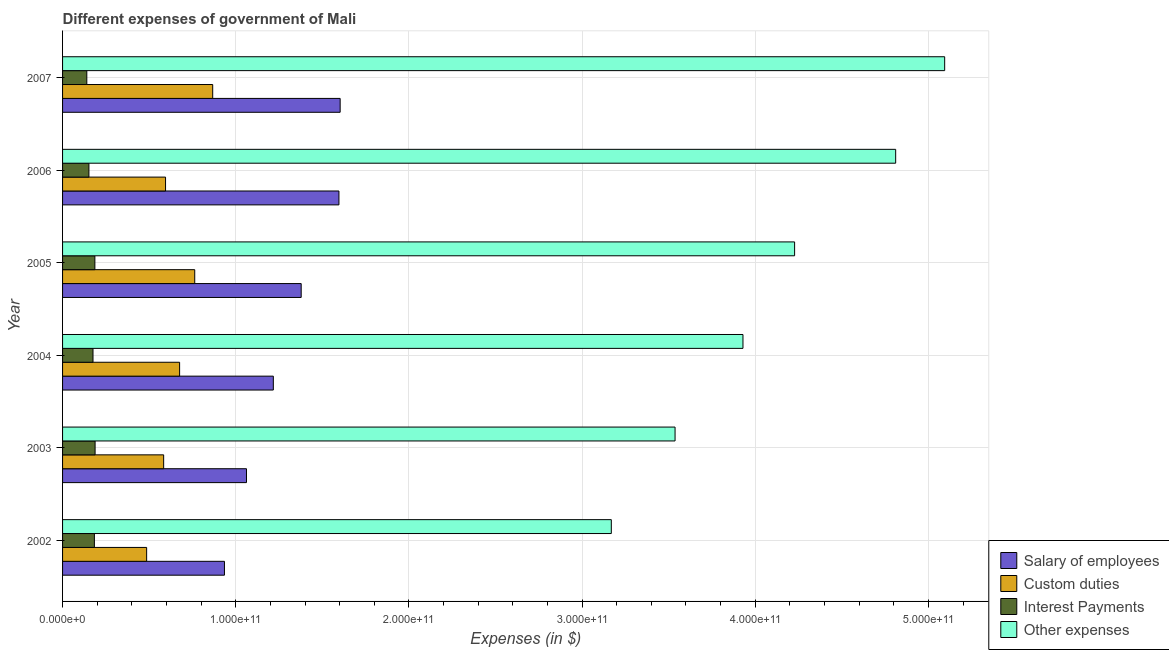How many different coloured bars are there?
Offer a very short reply. 4. What is the amount spent on custom duties in 2006?
Your answer should be very brief. 5.95e+1. Across all years, what is the maximum amount spent on interest payments?
Your response must be concise. 1.88e+1. Across all years, what is the minimum amount spent on custom duties?
Give a very brief answer. 4.86e+1. In which year was the amount spent on interest payments maximum?
Offer a terse response. 2003. In which year was the amount spent on interest payments minimum?
Your response must be concise. 2007. What is the total amount spent on custom duties in the graph?
Keep it short and to the point. 3.97e+11. What is the difference between the amount spent on custom duties in 2002 and that in 2006?
Make the answer very short. -1.09e+1. What is the difference between the amount spent on interest payments in 2004 and the amount spent on salary of employees in 2006?
Give a very brief answer. -1.42e+11. What is the average amount spent on interest payments per year?
Provide a succinct answer. 1.71e+1. In the year 2002, what is the difference between the amount spent on salary of employees and amount spent on other expenses?
Your answer should be compact. -2.23e+11. In how many years, is the amount spent on salary of employees greater than 320000000000 $?
Offer a terse response. 0. What is the ratio of the amount spent on salary of employees in 2003 to that in 2004?
Your response must be concise. 0.87. Is the difference between the amount spent on salary of employees in 2003 and 2004 greater than the difference between the amount spent on other expenses in 2003 and 2004?
Make the answer very short. Yes. What is the difference between the highest and the second highest amount spent on custom duties?
Provide a succinct answer. 1.04e+1. What is the difference between the highest and the lowest amount spent on other expenses?
Your response must be concise. 1.93e+11. In how many years, is the amount spent on interest payments greater than the average amount spent on interest payments taken over all years?
Keep it short and to the point. 4. Is the sum of the amount spent on custom duties in 2005 and 2006 greater than the maximum amount spent on other expenses across all years?
Give a very brief answer. No. What does the 3rd bar from the top in 2003 represents?
Offer a very short reply. Custom duties. What does the 4th bar from the bottom in 2003 represents?
Your response must be concise. Other expenses. How many bars are there?
Offer a very short reply. 24. Are all the bars in the graph horizontal?
Provide a short and direct response. Yes. What is the difference between two consecutive major ticks on the X-axis?
Your answer should be very brief. 1.00e+11. Does the graph contain any zero values?
Ensure brevity in your answer.  No. Does the graph contain grids?
Give a very brief answer. Yes. How many legend labels are there?
Provide a succinct answer. 4. What is the title of the graph?
Keep it short and to the point. Different expenses of government of Mali. What is the label or title of the X-axis?
Your answer should be compact. Expenses (in $). What is the label or title of the Y-axis?
Provide a succinct answer. Year. What is the Expenses (in $) in Salary of employees in 2002?
Your answer should be very brief. 9.35e+1. What is the Expenses (in $) of Custom duties in 2002?
Your response must be concise. 4.86e+1. What is the Expenses (in $) of Interest Payments in 2002?
Your answer should be compact. 1.84e+1. What is the Expenses (in $) in Other expenses in 2002?
Give a very brief answer. 3.17e+11. What is the Expenses (in $) in Salary of employees in 2003?
Offer a very short reply. 1.06e+11. What is the Expenses (in $) in Custom duties in 2003?
Offer a very short reply. 5.84e+1. What is the Expenses (in $) in Interest Payments in 2003?
Give a very brief answer. 1.88e+1. What is the Expenses (in $) in Other expenses in 2003?
Offer a very short reply. 3.54e+11. What is the Expenses (in $) in Salary of employees in 2004?
Provide a succinct answer. 1.22e+11. What is the Expenses (in $) of Custom duties in 2004?
Ensure brevity in your answer.  6.76e+1. What is the Expenses (in $) in Interest Payments in 2004?
Ensure brevity in your answer.  1.76e+1. What is the Expenses (in $) of Other expenses in 2004?
Provide a short and direct response. 3.93e+11. What is the Expenses (in $) in Salary of employees in 2005?
Provide a short and direct response. 1.38e+11. What is the Expenses (in $) of Custom duties in 2005?
Your answer should be very brief. 7.63e+1. What is the Expenses (in $) in Interest Payments in 2005?
Provide a succinct answer. 1.87e+1. What is the Expenses (in $) of Other expenses in 2005?
Provide a short and direct response. 4.23e+11. What is the Expenses (in $) in Salary of employees in 2006?
Offer a very short reply. 1.60e+11. What is the Expenses (in $) in Custom duties in 2006?
Provide a short and direct response. 5.95e+1. What is the Expenses (in $) in Interest Payments in 2006?
Your answer should be very brief. 1.52e+1. What is the Expenses (in $) in Other expenses in 2006?
Your answer should be very brief. 4.81e+11. What is the Expenses (in $) in Salary of employees in 2007?
Offer a very short reply. 1.60e+11. What is the Expenses (in $) in Custom duties in 2007?
Ensure brevity in your answer.  8.67e+1. What is the Expenses (in $) in Interest Payments in 2007?
Offer a very short reply. 1.40e+1. What is the Expenses (in $) of Other expenses in 2007?
Keep it short and to the point. 5.09e+11. Across all years, what is the maximum Expenses (in $) in Salary of employees?
Make the answer very short. 1.60e+11. Across all years, what is the maximum Expenses (in $) of Custom duties?
Your answer should be compact. 8.67e+1. Across all years, what is the maximum Expenses (in $) in Interest Payments?
Your answer should be very brief. 1.88e+1. Across all years, what is the maximum Expenses (in $) of Other expenses?
Your response must be concise. 5.09e+11. Across all years, what is the minimum Expenses (in $) of Salary of employees?
Provide a short and direct response. 9.35e+1. Across all years, what is the minimum Expenses (in $) in Custom duties?
Make the answer very short. 4.86e+1. Across all years, what is the minimum Expenses (in $) in Interest Payments?
Ensure brevity in your answer.  1.40e+1. Across all years, what is the minimum Expenses (in $) of Other expenses?
Give a very brief answer. 3.17e+11. What is the total Expenses (in $) in Salary of employees in the graph?
Your answer should be compact. 7.79e+11. What is the total Expenses (in $) of Custom duties in the graph?
Provide a short and direct response. 3.97e+11. What is the total Expenses (in $) in Interest Payments in the graph?
Offer a terse response. 1.03e+11. What is the total Expenses (in $) in Other expenses in the graph?
Your response must be concise. 2.48e+12. What is the difference between the Expenses (in $) in Salary of employees in 2002 and that in 2003?
Ensure brevity in your answer.  -1.27e+1. What is the difference between the Expenses (in $) of Custom duties in 2002 and that in 2003?
Offer a terse response. -9.82e+09. What is the difference between the Expenses (in $) of Interest Payments in 2002 and that in 2003?
Offer a very short reply. -4.08e+08. What is the difference between the Expenses (in $) in Other expenses in 2002 and that in 2003?
Ensure brevity in your answer.  -3.68e+1. What is the difference between the Expenses (in $) of Salary of employees in 2002 and that in 2004?
Offer a very short reply. -2.82e+1. What is the difference between the Expenses (in $) of Custom duties in 2002 and that in 2004?
Provide a short and direct response. -1.90e+1. What is the difference between the Expenses (in $) in Interest Payments in 2002 and that in 2004?
Offer a very short reply. 8.02e+08. What is the difference between the Expenses (in $) of Other expenses in 2002 and that in 2004?
Keep it short and to the point. -7.60e+1. What is the difference between the Expenses (in $) of Salary of employees in 2002 and that in 2005?
Provide a succinct answer. -4.43e+1. What is the difference between the Expenses (in $) of Custom duties in 2002 and that in 2005?
Your response must be concise. -2.78e+1. What is the difference between the Expenses (in $) of Interest Payments in 2002 and that in 2005?
Provide a succinct answer. -2.80e+08. What is the difference between the Expenses (in $) in Other expenses in 2002 and that in 2005?
Keep it short and to the point. -1.06e+11. What is the difference between the Expenses (in $) in Salary of employees in 2002 and that in 2006?
Your response must be concise. -6.61e+1. What is the difference between the Expenses (in $) in Custom duties in 2002 and that in 2006?
Provide a short and direct response. -1.09e+1. What is the difference between the Expenses (in $) in Interest Payments in 2002 and that in 2006?
Ensure brevity in your answer.  3.16e+09. What is the difference between the Expenses (in $) of Other expenses in 2002 and that in 2006?
Make the answer very short. -1.64e+11. What is the difference between the Expenses (in $) in Salary of employees in 2002 and that in 2007?
Offer a very short reply. -6.68e+1. What is the difference between the Expenses (in $) of Custom duties in 2002 and that in 2007?
Offer a terse response. -3.81e+1. What is the difference between the Expenses (in $) of Interest Payments in 2002 and that in 2007?
Offer a very short reply. 4.38e+09. What is the difference between the Expenses (in $) in Other expenses in 2002 and that in 2007?
Provide a succinct answer. -1.93e+11. What is the difference between the Expenses (in $) in Salary of employees in 2003 and that in 2004?
Make the answer very short. -1.55e+1. What is the difference between the Expenses (in $) in Custom duties in 2003 and that in 2004?
Your response must be concise. -9.22e+09. What is the difference between the Expenses (in $) in Interest Payments in 2003 and that in 2004?
Give a very brief answer. 1.21e+09. What is the difference between the Expenses (in $) in Other expenses in 2003 and that in 2004?
Make the answer very short. -3.92e+1. What is the difference between the Expenses (in $) in Salary of employees in 2003 and that in 2005?
Ensure brevity in your answer.  -3.16e+1. What is the difference between the Expenses (in $) in Custom duties in 2003 and that in 2005?
Ensure brevity in your answer.  -1.79e+1. What is the difference between the Expenses (in $) of Interest Payments in 2003 and that in 2005?
Your answer should be compact. 1.27e+08. What is the difference between the Expenses (in $) in Other expenses in 2003 and that in 2005?
Give a very brief answer. -6.90e+1. What is the difference between the Expenses (in $) of Salary of employees in 2003 and that in 2006?
Offer a very short reply. -5.34e+1. What is the difference between the Expenses (in $) in Custom duties in 2003 and that in 2006?
Offer a terse response. -1.10e+09. What is the difference between the Expenses (in $) in Interest Payments in 2003 and that in 2006?
Offer a terse response. 3.57e+09. What is the difference between the Expenses (in $) in Other expenses in 2003 and that in 2006?
Your answer should be compact. -1.27e+11. What is the difference between the Expenses (in $) of Salary of employees in 2003 and that in 2007?
Your answer should be very brief. -5.41e+1. What is the difference between the Expenses (in $) in Custom duties in 2003 and that in 2007?
Your answer should be compact. -2.83e+1. What is the difference between the Expenses (in $) of Interest Payments in 2003 and that in 2007?
Your answer should be very brief. 4.79e+09. What is the difference between the Expenses (in $) of Other expenses in 2003 and that in 2007?
Offer a very short reply. -1.56e+11. What is the difference between the Expenses (in $) in Salary of employees in 2004 and that in 2005?
Make the answer very short. -1.61e+1. What is the difference between the Expenses (in $) of Custom duties in 2004 and that in 2005?
Your answer should be very brief. -8.73e+09. What is the difference between the Expenses (in $) of Interest Payments in 2004 and that in 2005?
Offer a very short reply. -1.08e+09. What is the difference between the Expenses (in $) of Other expenses in 2004 and that in 2005?
Your answer should be very brief. -2.98e+1. What is the difference between the Expenses (in $) in Salary of employees in 2004 and that in 2006?
Offer a terse response. -3.79e+1. What is the difference between the Expenses (in $) in Custom duties in 2004 and that in 2006?
Make the answer very short. 8.12e+09. What is the difference between the Expenses (in $) in Interest Payments in 2004 and that in 2006?
Offer a very short reply. 2.36e+09. What is the difference between the Expenses (in $) of Other expenses in 2004 and that in 2006?
Provide a succinct answer. -8.82e+1. What is the difference between the Expenses (in $) of Salary of employees in 2004 and that in 2007?
Offer a very short reply. -3.86e+1. What is the difference between the Expenses (in $) in Custom duties in 2004 and that in 2007?
Provide a short and direct response. -1.91e+1. What is the difference between the Expenses (in $) in Interest Payments in 2004 and that in 2007?
Provide a succinct answer. 3.58e+09. What is the difference between the Expenses (in $) in Other expenses in 2004 and that in 2007?
Your answer should be compact. -1.16e+11. What is the difference between the Expenses (in $) of Salary of employees in 2005 and that in 2006?
Your response must be concise. -2.18e+1. What is the difference between the Expenses (in $) in Custom duties in 2005 and that in 2006?
Make the answer very short. 1.68e+1. What is the difference between the Expenses (in $) in Interest Payments in 2005 and that in 2006?
Give a very brief answer. 3.44e+09. What is the difference between the Expenses (in $) in Other expenses in 2005 and that in 2006?
Give a very brief answer. -5.84e+1. What is the difference between the Expenses (in $) in Salary of employees in 2005 and that in 2007?
Keep it short and to the point. -2.25e+1. What is the difference between the Expenses (in $) of Custom duties in 2005 and that in 2007?
Ensure brevity in your answer.  -1.04e+1. What is the difference between the Expenses (in $) of Interest Payments in 2005 and that in 2007?
Provide a short and direct response. 4.66e+09. What is the difference between the Expenses (in $) of Other expenses in 2005 and that in 2007?
Your answer should be very brief. -8.67e+1. What is the difference between the Expenses (in $) of Salary of employees in 2006 and that in 2007?
Your answer should be compact. -7.02e+08. What is the difference between the Expenses (in $) of Custom duties in 2006 and that in 2007?
Ensure brevity in your answer.  -2.72e+1. What is the difference between the Expenses (in $) in Interest Payments in 2006 and that in 2007?
Your response must be concise. 1.22e+09. What is the difference between the Expenses (in $) of Other expenses in 2006 and that in 2007?
Your response must be concise. -2.83e+1. What is the difference between the Expenses (in $) in Salary of employees in 2002 and the Expenses (in $) in Custom duties in 2003?
Offer a very short reply. 3.51e+1. What is the difference between the Expenses (in $) in Salary of employees in 2002 and the Expenses (in $) in Interest Payments in 2003?
Provide a short and direct response. 7.47e+1. What is the difference between the Expenses (in $) of Salary of employees in 2002 and the Expenses (in $) of Other expenses in 2003?
Provide a succinct answer. -2.60e+11. What is the difference between the Expenses (in $) of Custom duties in 2002 and the Expenses (in $) of Interest Payments in 2003?
Keep it short and to the point. 2.98e+1. What is the difference between the Expenses (in $) in Custom duties in 2002 and the Expenses (in $) in Other expenses in 2003?
Provide a short and direct response. -3.05e+11. What is the difference between the Expenses (in $) in Interest Payments in 2002 and the Expenses (in $) in Other expenses in 2003?
Give a very brief answer. -3.35e+11. What is the difference between the Expenses (in $) in Salary of employees in 2002 and the Expenses (in $) in Custom duties in 2004?
Your answer should be very brief. 2.59e+1. What is the difference between the Expenses (in $) of Salary of employees in 2002 and the Expenses (in $) of Interest Payments in 2004?
Provide a short and direct response. 7.59e+1. What is the difference between the Expenses (in $) in Salary of employees in 2002 and the Expenses (in $) in Other expenses in 2004?
Make the answer very short. -2.99e+11. What is the difference between the Expenses (in $) in Custom duties in 2002 and the Expenses (in $) in Interest Payments in 2004?
Your answer should be compact. 3.10e+1. What is the difference between the Expenses (in $) in Custom duties in 2002 and the Expenses (in $) in Other expenses in 2004?
Offer a very short reply. -3.44e+11. What is the difference between the Expenses (in $) in Interest Payments in 2002 and the Expenses (in $) in Other expenses in 2004?
Keep it short and to the point. -3.75e+11. What is the difference between the Expenses (in $) in Salary of employees in 2002 and the Expenses (in $) in Custom duties in 2005?
Give a very brief answer. 1.72e+1. What is the difference between the Expenses (in $) of Salary of employees in 2002 and the Expenses (in $) of Interest Payments in 2005?
Provide a short and direct response. 7.48e+1. What is the difference between the Expenses (in $) in Salary of employees in 2002 and the Expenses (in $) in Other expenses in 2005?
Make the answer very short. -3.29e+11. What is the difference between the Expenses (in $) of Custom duties in 2002 and the Expenses (in $) of Interest Payments in 2005?
Keep it short and to the point. 2.99e+1. What is the difference between the Expenses (in $) in Custom duties in 2002 and the Expenses (in $) in Other expenses in 2005?
Provide a succinct answer. -3.74e+11. What is the difference between the Expenses (in $) in Interest Payments in 2002 and the Expenses (in $) in Other expenses in 2005?
Your answer should be compact. -4.04e+11. What is the difference between the Expenses (in $) in Salary of employees in 2002 and the Expenses (in $) in Custom duties in 2006?
Provide a short and direct response. 3.40e+1. What is the difference between the Expenses (in $) of Salary of employees in 2002 and the Expenses (in $) of Interest Payments in 2006?
Make the answer very short. 7.83e+1. What is the difference between the Expenses (in $) in Salary of employees in 2002 and the Expenses (in $) in Other expenses in 2006?
Your answer should be compact. -3.88e+11. What is the difference between the Expenses (in $) of Custom duties in 2002 and the Expenses (in $) of Interest Payments in 2006?
Ensure brevity in your answer.  3.33e+1. What is the difference between the Expenses (in $) in Custom duties in 2002 and the Expenses (in $) in Other expenses in 2006?
Offer a very short reply. -4.33e+11. What is the difference between the Expenses (in $) in Interest Payments in 2002 and the Expenses (in $) in Other expenses in 2006?
Provide a short and direct response. -4.63e+11. What is the difference between the Expenses (in $) in Salary of employees in 2002 and the Expenses (in $) in Custom duties in 2007?
Ensure brevity in your answer.  6.79e+09. What is the difference between the Expenses (in $) in Salary of employees in 2002 and the Expenses (in $) in Interest Payments in 2007?
Your response must be concise. 7.95e+1. What is the difference between the Expenses (in $) of Salary of employees in 2002 and the Expenses (in $) of Other expenses in 2007?
Your answer should be compact. -4.16e+11. What is the difference between the Expenses (in $) of Custom duties in 2002 and the Expenses (in $) of Interest Payments in 2007?
Offer a very short reply. 3.46e+1. What is the difference between the Expenses (in $) of Custom duties in 2002 and the Expenses (in $) of Other expenses in 2007?
Make the answer very short. -4.61e+11. What is the difference between the Expenses (in $) in Interest Payments in 2002 and the Expenses (in $) in Other expenses in 2007?
Your response must be concise. -4.91e+11. What is the difference between the Expenses (in $) of Salary of employees in 2003 and the Expenses (in $) of Custom duties in 2004?
Keep it short and to the point. 3.86e+1. What is the difference between the Expenses (in $) in Salary of employees in 2003 and the Expenses (in $) in Interest Payments in 2004?
Your answer should be compact. 8.86e+1. What is the difference between the Expenses (in $) of Salary of employees in 2003 and the Expenses (in $) of Other expenses in 2004?
Give a very brief answer. -2.87e+11. What is the difference between the Expenses (in $) in Custom duties in 2003 and the Expenses (in $) in Interest Payments in 2004?
Keep it short and to the point. 4.08e+1. What is the difference between the Expenses (in $) in Custom duties in 2003 and the Expenses (in $) in Other expenses in 2004?
Provide a succinct answer. -3.35e+11. What is the difference between the Expenses (in $) in Interest Payments in 2003 and the Expenses (in $) in Other expenses in 2004?
Keep it short and to the point. -3.74e+11. What is the difference between the Expenses (in $) in Salary of employees in 2003 and the Expenses (in $) in Custom duties in 2005?
Keep it short and to the point. 2.99e+1. What is the difference between the Expenses (in $) of Salary of employees in 2003 and the Expenses (in $) of Interest Payments in 2005?
Provide a succinct answer. 8.75e+1. What is the difference between the Expenses (in $) in Salary of employees in 2003 and the Expenses (in $) in Other expenses in 2005?
Your response must be concise. -3.17e+11. What is the difference between the Expenses (in $) of Custom duties in 2003 and the Expenses (in $) of Interest Payments in 2005?
Provide a short and direct response. 3.97e+1. What is the difference between the Expenses (in $) in Custom duties in 2003 and the Expenses (in $) in Other expenses in 2005?
Your answer should be compact. -3.64e+11. What is the difference between the Expenses (in $) in Interest Payments in 2003 and the Expenses (in $) in Other expenses in 2005?
Offer a very short reply. -4.04e+11. What is the difference between the Expenses (in $) in Salary of employees in 2003 and the Expenses (in $) in Custom duties in 2006?
Keep it short and to the point. 4.67e+1. What is the difference between the Expenses (in $) of Salary of employees in 2003 and the Expenses (in $) of Interest Payments in 2006?
Keep it short and to the point. 9.10e+1. What is the difference between the Expenses (in $) in Salary of employees in 2003 and the Expenses (in $) in Other expenses in 2006?
Make the answer very short. -3.75e+11. What is the difference between the Expenses (in $) of Custom duties in 2003 and the Expenses (in $) of Interest Payments in 2006?
Keep it short and to the point. 4.32e+1. What is the difference between the Expenses (in $) in Custom duties in 2003 and the Expenses (in $) in Other expenses in 2006?
Your answer should be compact. -4.23e+11. What is the difference between the Expenses (in $) of Interest Payments in 2003 and the Expenses (in $) of Other expenses in 2006?
Offer a very short reply. -4.62e+11. What is the difference between the Expenses (in $) in Salary of employees in 2003 and the Expenses (in $) in Custom duties in 2007?
Your answer should be very brief. 1.95e+1. What is the difference between the Expenses (in $) of Salary of employees in 2003 and the Expenses (in $) of Interest Payments in 2007?
Provide a succinct answer. 9.22e+1. What is the difference between the Expenses (in $) of Salary of employees in 2003 and the Expenses (in $) of Other expenses in 2007?
Ensure brevity in your answer.  -4.03e+11. What is the difference between the Expenses (in $) in Custom duties in 2003 and the Expenses (in $) in Interest Payments in 2007?
Keep it short and to the point. 4.44e+1. What is the difference between the Expenses (in $) of Custom duties in 2003 and the Expenses (in $) of Other expenses in 2007?
Keep it short and to the point. -4.51e+11. What is the difference between the Expenses (in $) of Interest Payments in 2003 and the Expenses (in $) of Other expenses in 2007?
Provide a succinct answer. -4.91e+11. What is the difference between the Expenses (in $) in Salary of employees in 2004 and the Expenses (in $) in Custom duties in 2005?
Your answer should be compact. 4.54e+1. What is the difference between the Expenses (in $) in Salary of employees in 2004 and the Expenses (in $) in Interest Payments in 2005?
Keep it short and to the point. 1.03e+11. What is the difference between the Expenses (in $) in Salary of employees in 2004 and the Expenses (in $) in Other expenses in 2005?
Your answer should be compact. -3.01e+11. What is the difference between the Expenses (in $) in Custom duties in 2004 and the Expenses (in $) in Interest Payments in 2005?
Provide a succinct answer. 4.89e+1. What is the difference between the Expenses (in $) of Custom duties in 2004 and the Expenses (in $) of Other expenses in 2005?
Make the answer very short. -3.55e+11. What is the difference between the Expenses (in $) in Interest Payments in 2004 and the Expenses (in $) in Other expenses in 2005?
Your answer should be compact. -4.05e+11. What is the difference between the Expenses (in $) in Salary of employees in 2004 and the Expenses (in $) in Custom duties in 2006?
Ensure brevity in your answer.  6.22e+1. What is the difference between the Expenses (in $) of Salary of employees in 2004 and the Expenses (in $) of Interest Payments in 2006?
Your response must be concise. 1.06e+11. What is the difference between the Expenses (in $) in Salary of employees in 2004 and the Expenses (in $) in Other expenses in 2006?
Your answer should be very brief. -3.59e+11. What is the difference between the Expenses (in $) of Custom duties in 2004 and the Expenses (in $) of Interest Payments in 2006?
Make the answer very short. 5.24e+1. What is the difference between the Expenses (in $) in Custom duties in 2004 and the Expenses (in $) in Other expenses in 2006?
Your answer should be compact. -4.14e+11. What is the difference between the Expenses (in $) of Interest Payments in 2004 and the Expenses (in $) of Other expenses in 2006?
Make the answer very short. -4.64e+11. What is the difference between the Expenses (in $) in Salary of employees in 2004 and the Expenses (in $) in Custom duties in 2007?
Keep it short and to the point. 3.50e+1. What is the difference between the Expenses (in $) in Salary of employees in 2004 and the Expenses (in $) in Interest Payments in 2007?
Give a very brief answer. 1.08e+11. What is the difference between the Expenses (in $) in Salary of employees in 2004 and the Expenses (in $) in Other expenses in 2007?
Ensure brevity in your answer.  -3.88e+11. What is the difference between the Expenses (in $) of Custom duties in 2004 and the Expenses (in $) of Interest Payments in 2007?
Your response must be concise. 5.36e+1. What is the difference between the Expenses (in $) of Custom duties in 2004 and the Expenses (in $) of Other expenses in 2007?
Make the answer very short. -4.42e+11. What is the difference between the Expenses (in $) in Interest Payments in 2004 and the Expenses (in $) in Other expenses in 2007?
Your answer should be very brief. -4.92e+11. What is the difference between the Expenses (in $) of Salary of employees in 2005 and the Expenses (in $) of Custom duties in 2006?
Keep it short and to the point. 7.83e+1. What is the difference between the Expenses (in $) of Salary of employees in 2005 and the Expenses (in $) of Interest Payments in 2006?
Your response must be concise. 1.23e+11. What is the difference between the Expenses (in $) of Salary of employees in 2005 and the Expenses (in $) of Other expenses in 2006?
Offer a terse response. -3.43e+11. What is the difference between the Expenses (in $) of Custom duties in 2005 and the Expenses (in $) of Interest Payments in 2006?
Offer a very short reply. 6.11e+1. What is the difference between the Expenses (in $) of Custom duties in 2005 and the Expenses (in $) of Other expenses in 2006?
Offer a very short reply. -4.05e+11. What is the difference between the Expenses (in $) in Interest Payments in 2005 and the Expenses (in $) in Other expenses in 2006?
Offer a terse response. -4.62e+11. What is the difference between the Expenses (in $) in Salary of employees in 2005 and the Expenses (in $) in Custom duties in 2007?
Your answer should be very brief. 5.11e+1. What is the difference between the Expenses (in $) in Salary of employees in 2005 and the Expenses (in $) in Interest Payments in 2007?
Provide a succinct answer. 1.24e+11. What is the difference between the Expenses (in $) of Salary of employees in 2005 and the Expenses (in $) of Other expenses in 2007?
Your answer should be compact. -3.72e+11. What is the difference between the Expenses (in $) of Custom duties in 2005 and the Expenses (in $) of Interest Payments in 2007?
Make the answer very short. 6.23e+1. What is the difference between the Expenses (in $) in Custom duties in 2005 and the Expenses (in $) in Other expenses in 2007?
Your answer should be compact. -4.33e+11. What is the difference between the Expenses (in $) in Interest Payments in 2005 and the Expenses (in $) in Other expenses in 2007?
Your answer should be compact. -4.91e+11. What is the difference between the Expenses (in $) in Salary of employees in 2006 and the Expenses (in $) in Custom duties in 2007?
Give a very brief answer. 7.29e+1. What is the difference between the Expenses (in $) of Salary of employees in 2006 and the Expenses (in $) of Interest Payments in 2007?
Ensure brevity in your answer.  1.46e+11. What is the difference between the Expenses (in $) of Salary of employees in 2006 and the Expenses (in $) of Other expenses in 2007?
Ensure brevity in your answer.  -3.50e+11. What is the difference between the Expenses (in $) of Custom duties in 2006 and the Expenses (in $) of Interest Payments in 2007?
Give a very brief answer. 4.55e+1. What is the difference between the Expenses (in $) of Custom duties in 2006 and the Expenses (in $) of Other expenses in 2007?
Keep it short and to the point. -4.50e+11. What is the difference between the Expenses (in $) in Interest Payments in 2006 and the Expenses (in $) in Other expenses in 2007?
Provide a succinct answer. -4.94e+11. What is the average Expenses (in $) of Salary of employees per year?
Your answer should be compact. 1.30e+11. What is the average Expenses (in $) of Custom duties per year?
Your response must be concise. 6.62e+1. What is the average Expenses (in $) of Interest Payments per year?
Keep it short and to the point. 1.71e+1. What is the average Expenses (in $) of Other expenses per year?
Keep it short and to the point. 4.13e+11. In the year 2002, what is the difference between the Expenses (in $) of Salary of employees and Expenses (in $) of Custom duties?
Your answer should be very brief. 4.49e+1. In the year 2002, what is the difference between the Expenses (in $) of Salary of employees and Expenses (in $) of Interest Payments?
Offer a very short reply. 7.51e+1. In the year 2002, what is the difference between the Expenses (in $) of Salary of employees and Expenses (in $) of Other expenses?
Your answer should be compact. -2.23e+11. In the year 2002, what is the difference between the Expenses (in $) of Custom duties and Expenses (in $) of Interest Payments?
Offer a terse response. 3.02e+1. In the year 2002, what is the difference between the Expenses (in $) in Custom duties and Expenses (in $) in Other expenses?
Provide a short and direct response. -2.68e+11. In the year 2002, what is the difference between the Expenses (in $) of Interest Payments and Expenses (in $) of Other expenses?
Your answer should be compact. -2.99e+11. In the year 2003, what is the difference between the Expenses (in $) in Salary of employees and Expenses (in $) in Custom duties?
Offer a very short reply. 4.78e+1. In the year 2003, what is the difference between the Expenses (in $) in Salary of employees and Expenses (in $) in Interest Payments?
Your response must be concise. 8.74e+1. In the year 2003, what is the difference between the Expenses (in $) of Salary of employees and Expenses (in $) of Other expenses?
Keep it short and to the point. -2.47e+11. In the year 2003, what is the difference between the Expenses (in $) of Custom duties and Expenses (in $) of Interest Payments?
Your answer should be compact. 3.96e+1. In the year 2003, what is the difference between the Expenses (in $) of Custom duties and Expenses (in $) of Other expenses?
Your response must be concise. -2.95e+11. In the year 2003, what is the difference between the Expenses (in $) of Interest Payments and Expenses (in $) of Other expenses?
Provide a short and direct response. -3.35e+11. In the year 2004, what is the difference between the Expenses (in $) in Salary of employees and Expenses (in $) in Custom duties?
Ensure brevity in your answer.  5.41e+1. In the year 2004, what is the difference between the Expenses (in $) in Salary of employees and Expenses (in $) in Interest Payments?
Ensure brevity in your answer.  1.04e+11. In the year 2004, what is the difference between the Expenses (in $) of Salary of employees and Expenses (in $) of Other expenses?
Provide a short and direct response. -2.71e+11. In the year 2004, what is the difference between the Expenses (in $) in Custom duties and Expenses (in $) in Interest Payments?
Ensure brevity in your answer.  5.00e+1. In the year 2004, what is the difference between the Expenses (in $) in Custom duties and Expenses (in $) in Other expenses?
Provide a succinct answer. -3.25e+11. In the year 2004, what is the difference between the Expenses (in $) in Interest Payments and Expenses (in $) in Other expenses?
Provide a succinct answer. -3.75e+11. In the year 2005, what is the difference between the Expenses (in $) of Salary of employees and Expenses (in $) of Custom duties?
Your answer should be compact. 6.15e+1. In the year 2005, what is the difference between the Expenses (in $) of Salary of employees and Expenses (in $) of Interest Payments?
Offer a very short reply. 1.19e+11. In the year 2005, what is the difference between the Expenses (in $) in Salary of employees and Expenses (in $) in Other expenses?
Provide a succinct answer. -2.85e+11. In the year 2005, what is the difference between the Expenses (in $) in Custom duties and Expenses (in $) in Interest Payments?
Make the answer very short. 5.77e+1. In the year 2005, what is the difference between the Expenses (in $) in Custom duties and Expenses (in $) in Other expenses?
Provide a short and direct response. -3.46e+11. In the year 2005, what is the difference between the Expenses (in $) of Interest Payments and Expenses (in $) of Other expenses?
Offer a terse response. -4.04e+11. In the year 2006, what is the difference between the Expenses (in $) in Salary of employees and Expenses (in $) in Custom duties?
Give a very brief answer. 1.00e+11. In the year 2006, what is the difference between the Expenses (in $) of Salary of employees and Expenses (in $) of Interest Payments?
Provide a short and direct response. 1.44e+11. In the year 2006, what is the difference between the Expenses (in $) in Salary of employees and Expenses (in $) in Other expenses?
Your answer should be very brief. -3.22e+11. In the year 2006, what is the difference between the Expenses (in $) of Custom duties and Expenses (in $) of Interest Payments?
Provide a succinct answer. 4.43e+1. In the year 2006, what is the difference between the Expenses (in $) of Custom duties and Expenses (in $) of Other expenses?
Make the answer very short. -4.22e+11. In the year 2006, what is the difference between the Expenses (in $) of Interest Payments and Expenses (in $) of Other expenses?
Offer a terse response. -4.66e+11. In the year 2007, what is the difference between the Expenses (in $) in Salary of employees and Expenses (in $) in Custom duties?
Provide a short and direct response. 7.36e+1. In the year 2007, what is the difference between the Expenses (in $) of Salary of employees and Expenses (in $) of Interest Payments?
Your response must be concise. 1.46e+11. In the year 2007, what is the difference between the Expenses (in $) of Salary of employees and Expenses (in $) of Other expenses?
Offer a very short reply. -3.49e+11. In the year 2007, what is the difference between the Expenses (in $) of Custom duties and Expenses (in $) of Interest Payments?
Your response must be concise. 7.27e+1. In the year 2007, what is the difference between the Expenses (in $) of Custom duties and Expenses (in $) of Other expenses?
Offer a terse response. -4.23e+11. In the year 2007, what is the difference between the Expenses (in $) of Interest Payments and Expenses (in $) of Other expenses?
Provide a succinct answer. -4.95e+11. What is the ratio of the Expenses (in $) in Salary of employees in 2002 to that in 2003?
Offer a terse response. 0.88. What is the ratio of the Expenses (in $) in Custom duties in 2002 to that in 2003?
Provide a short and direct response. 0.83. What is the ratio of the Expenses (in $) in Interest Payments in 2002 to that in 2003?
Your answer should be compact. 0.98. What is the ratio of the Expenses (in $) of Other expenses in 2002 to that in 2003?
Give a very brief answer. 0.9. What is the ratio of the Expenses (in $) in Salary of employees in 2002 to that in 2004?
Your response must be concise. 0.77. What is the ratio of the Expenses (in $) of Custom duties in 2002 to that in 2004?
Ensure brevity in your answer.  0.72. What is the ratio of the Expenses (in $) of Interest Payments in 2002 to that in 2004?
Provide a short and direct response. 1.05. What is the ratio of the Expenses (in $) of Other expenses in 2002 to that in 2004?
Make the answer very short. 0.81. What is the ratio of the Expenses (in $) in Salary of employees in 2002 to that in 2005?
Your answer should be compact. 0.68. What is the ratio of the Expenses (in $) of Custom duties in 2002 to that in 2005?
Your answer should be very brief. 0.64. What is the ratio of the Expenses (in $) in Other expenses in 2002 to that in 2005?
Your answer should be very brief. 0.75. What is the ratio of the Expenses (in $) of Salary of employees in 2002 to that in 2006?
Keep it short and to the point. 0.59. What is the ratio of the Expenses (in $) in Custom duties in 2002 to that in 2006?
Give a very brief answer. 0.82. What is the ratio of the Expenses (in $) in Interest Payments in 2002 to that in 2006?
Your response must be concise. 1.21. What is the ratio of the Expenses (in $) of Other expenses in 2002 to that in 2006?
Make the answer very short. 0.66. What is the ratio of the Expenses (in $) of Salary of employees in 2002 to that in 2007?
Make the answer very short. 0.58. What is the ratio of the Expenses (in $) in Custom duties in 2002 to that in 2007?
Keep it short and to the point. 0.56. What is the ratio of the Expenses (in $) of Interest Payments in 2002 to that in 2007?
Your answer should be compact. 1.31. What is the ratio of the Expenses (in $) in Other expenses in 2002 to that in 2007?
Ensure brevity in your answer.  0.62. What is the ratio of the Expenses (in $) in Salary of employees in 2003 to that in 2004?
Provide a short and direct response. 0.87. What is the ratio of the Expenses (in $) of Custom duties in 2003 to that in 2004?
Your response must be concise. 0.86. What is the ratio of the Expenses (in $) in Interest Payments in 2003 to that in 2004?
Provide a short and direct response. 1.07. What is the ratio of the Expenses (in $) of Other expenses in 2003 to that in 2004?
Offer a very short reply. 0.9. What is the ratio of the Expenses (in $) of Salary of employees in 2003 to that in 2005?
Give a very brief answer. 0.77. What is the ratio of the Expenses (in $) of Custom duties in 2003 to that in 2005?
Your answer should be compact. 0.76. What is the ratio of the Expenses (in $) of Interest Payments in 2003 to that in 2005?
Make the answer very short. 1.01. What is the ratio of the Expenses (in $) of Other expenses in 2003 to that in 2005?
Give a very brief answer. 0.84. What is the ratio of the Expenses (in $) of Salary of employees in 2003 to that in 2006?
Ensure brevity in your answer.  0.67. What is the ratio of the Expenses (in $) in Custom duties in 2003 to that in 2006?
Offer a terse response. 0.98. What is the ratio of the Expenses (in $) of Interest Payments in 2003 to that in 2006?
Provide a short and direct response. 1.23. What is the ratio of the Expenses (in $) of Other expenses in 2003 to that in 2006?
Make the answer very short. 0.74. What is the ratio of the Expenses (in $) in Salary of employees in 2003 to that in 2007?
Keep it short and to the point. 0.66. What is the ratio of the Expenses (in $) in Custom duties in 2003 to that in 2007?
Provide a short and direct response. 0.67. What is the ratio of the Expenses (in $) of Interest Payments in 2003 to that in 2007?
Keep it short and to the point. 1.34. What is the ratio of the Expenses (in $) in Other expenses in 2003 to that in 2007?
Provide a short and direct response. 0.69. What is the ratio of the Expenses (in $) of Salary of employees in 2004 to that in 2005?
Your answer should be compact. 0.88. What is the ratio of the Expenses (in $) in Custom duties in 2004 to that in 2005?
Give a very brief answer. 0.89. What is the ratio of the Expenses (in $) in Interest Payments in 2004 to that in 2005?
Offer a very short reply. 0.94. What is the ratio of the Expenses (in $) of Other expenses in 2004 to that in 2005?
Provide a succinct answer. 0.93. What is the ratio of the Expenses (in $) in Salary of employees in 2004 to that in 2006?
Your answer should be very brief. 0.76. What is the ratio of the Expenses (in $) in Custom duties in 2004 to that in 2006?
Keep it short and to the point. 1.14. What is the ratio of the Expenses (in $) in Interest Payments in 2004 to that in 2006?
Provide a succinct answer. 1.15. What is the ratio of the Expenses (in $) of Other expenses in 2004 to that in 2006?
Your answer should be compact. 0.82. What is the ratio of the Expenses (in $) in Salary of employees in 2004 to that in 2007?
Provide a short and direct response. 0.76. What is the ratio of the Expenses (in $) in Custom duties in 2004 to that in 2007?
Provide a short and direct response. 0.78. What is the ratio of the Expenses (in $) in Interest Payments in 2004 to that in 2007?
Offer a terse response. 1.26. What is the ratio of the Expenses (in $) in Other expenses in 2004 to that in 2007?
Offer a terse response. 0.77. What is the ratio of the Expenses (in $) of Salary of employees in 2005 to that in 2006?
Your answer should be very brief. 0.86. What is the ratio of the Expenses (in $) of Custom duties in 2005 to that in 2006?
Keep it short and to the point. 1.28. What is the ratio of the Expenses (in $) in Interest Payments in 2005 to that in 2006?
Ensure brevity in your answer.  1.23. What is the ratio of the Expenses (in $) in Other expenses in 2005 to that in 2006?
Give a very brief answer. 0.88. What is the ratio of the Expenses (in $) of Salary of employees in 2005 to that in 2007?
Your answer should be very brief. 0.86. What is the ratio of the Expenses (in $) of Custom duties in 2005 to that in 2007?
Give a very brief answer. 0.88. What is the ratio of the Expenses (in $) of Interest Payments in 2005 to that in 2007?
Give a very brief answer. 1.33. What is the ratio of the Expenses (in $) in Other expenses in 2005 to that in 2007?
Your answer should be compact. 0.83. What is the ratio of the Expenses (in $) in Custom duties in 2006 to that in 2007?
Keep it short and to the point. 0.69. What is the ratio of the Expenses (in $) of Interest Payments in 2006 to that in 2007?
Provide a short and direct response. 1.09. What is the ratio of the Expenses (in $) of Other expenses in 2006 to that in 2007?
Keep it short and to the point. 0.94. What is the difference between the highest and the second highest Expenses (in $) of Salary of employees?
Offer a terse response. 7.02e+08. What is the difference between the highest and the second highest Expenses (in $) of Custom duties?
Keep it short and to the point. 1.04e+1. What is the difference between the highest and the second highest Expenses (in $) of Interest Payments?
Give a very brief answer. 1.27e+08. What is the difference between the highest and the second highest Expenses (in $) of Other expenses?
Your answer should be compact. 2.83e+1. What is the difference between the highest and the lowest Expenses (in $) of Salary of employees?
Your answer should be very brief. 6.68e+1. What is the difference between the highest and the lowest Expenses (in $) of Custom duties?
Your answer should be very brief. 3.81e+1. What is the difference between the highest and the lowest Expenses (in $) of Interest Payments?
Offer a very short reply. 4.79e+09. What is the difference between the highest and the lowest Expenses (in $) of Other expenses?
Your response must be concise. 1.93e+11. 